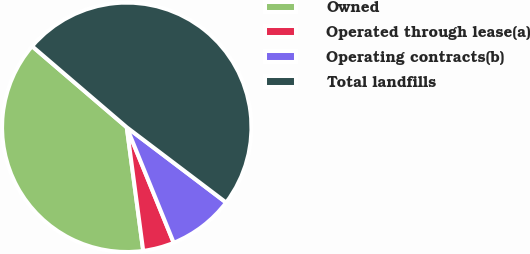Convert chart. <chart><loc_0><loc_0><loc_500><loc_500><pie_chart><fcel>Owned<fcel>Operated through lease(a)<fcel>Operating contracts(b)<fcel>Total landfills<nl><fcel>38.38%<fcel>4.04%<fcel>8.54%<fcel>49.04%<nl></chart> 